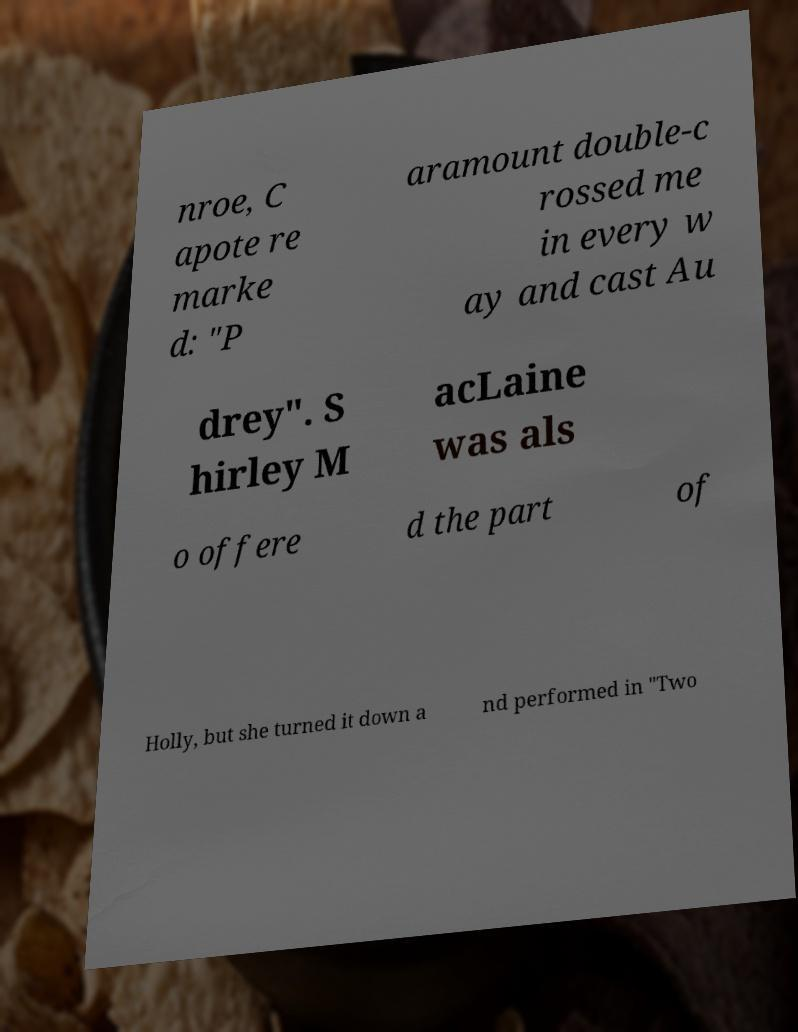Can you accurately transcribe the text from the provided image for me? nroe, C apote re marke d: "P aramount double-c rossed me in every w ay and cast Au drey". S hirley M acLaine was als o offere d the part of Holly, but she turned it down a nd performed in "Two 